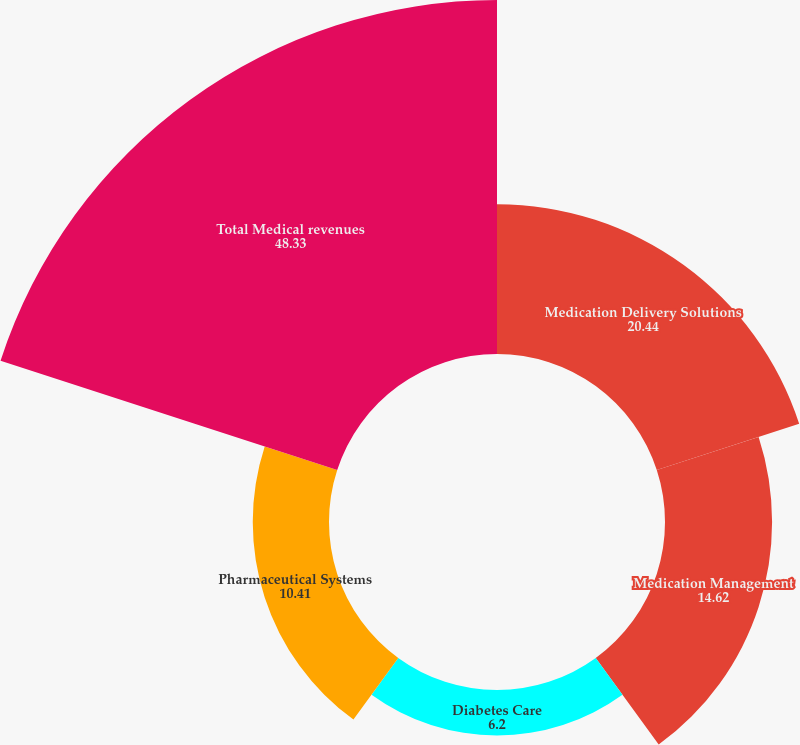<chart> <loc_0><loc_0><loc_500><loc_500><pie_chart><fcel>Medication Delivery Solutions<fcel>Medication Management<fcel>Diabetes Care<fcel>Pharmaceutical Systems<fcel>Total Medical revenues<nl><fcel>20.44%<fcel>14.62%<fcel>6.2%<fcel>10.41%<fcel>48.33%<nl></chart> 